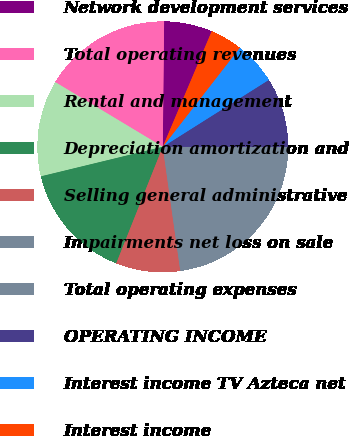Convert chart to OTSL. <chart><loc_0><loc_0><loc_500><loc_500><pie_chart><fcel>Network development services<fcel>Total operating revenues<fcel>Rental and management<fcel>Depreciation amortization and<fcel>Selling general administrative<fcel>Impairments net loss on sale<fcel>Total operating expenses<fcel>OPERATING INCOME<fcel>Interest income TV Azteca net<fcel>Interest income<nl><fcel>6.21%<fcel>16.55%<fcel>12.41%<fcel>15.17%<fcel>8.28%<fcel>6.9%<fcel>15.86%<fcel>8.97%<fcel>5.52%<fcel>4.14%<nl></chart> 